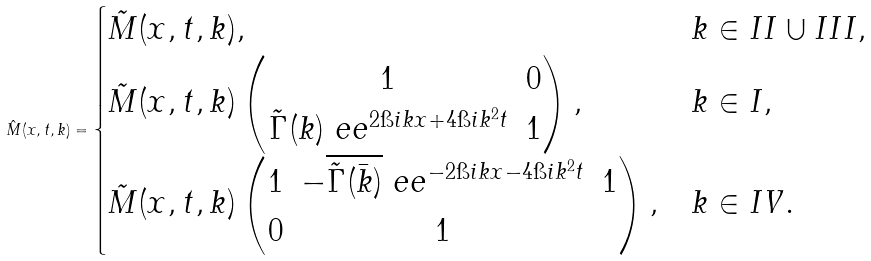<formula> <loc_0><loc_0><loc_500><loc_500>\hat { M } ( x , t , k ) = \begin{cases} \tilde { M } ( x , t , k ) , & k \in I I \cup I I I , \\ \tilde { M } ( x , t , k ) \begin{pmatrix} 1 & 0 \\ \tilde { \Gamma } ( k ) \ e e ^ { 2 \i i k x + 4 \i i k ^ { 2 } t } & 1 \end{pmatrix} , & k \in I , \\ \tilde { M } ( x , t , k ) \begin{pmatrix} 1 & - \overline { \tilde { \Gamma } ( \bar { k } ) } \ e e ^ { - 2 \i i k x - 4 \i i k ^ { 2 } t } & 1 \\ 0 & 1 \end{pmatrix} , & k \in I V . \end{cases}</formula> 